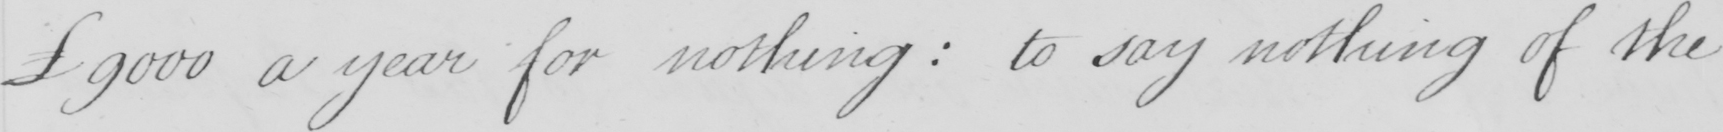Please transcribe the handwritten text in this image. £9000 a year for nothing :  to say nothing of the 